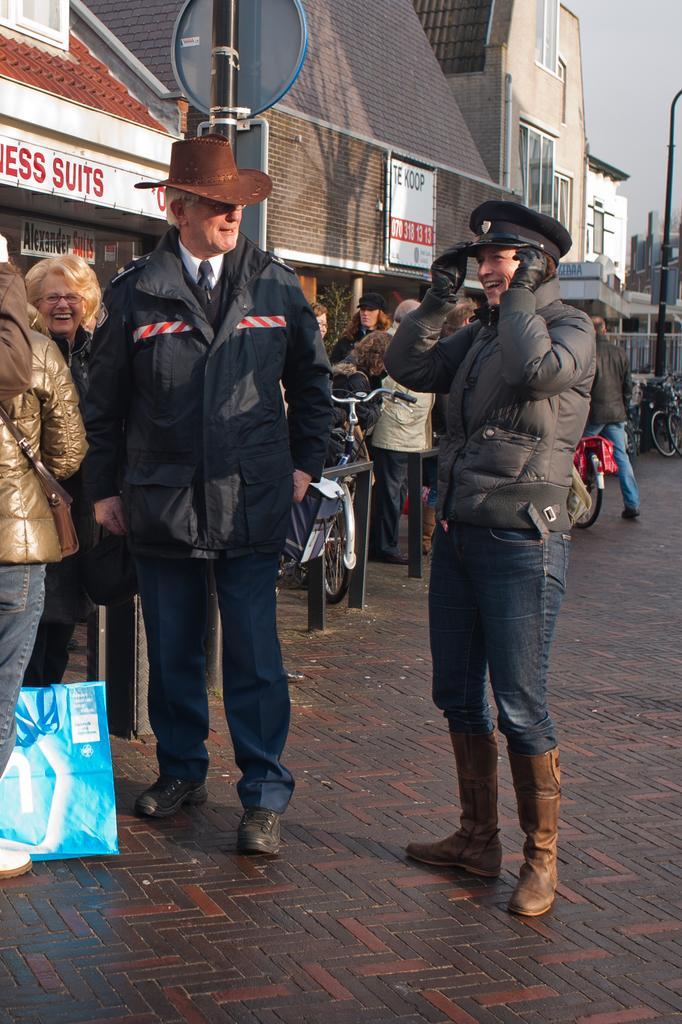In one or two sentences, can you explain what this image depicts? In the center of the image we can see two people standing and smiling. In the background there are people standing and we can see a bicycle. On the left there are buildings. We can see a pole. At the top there is sky. 